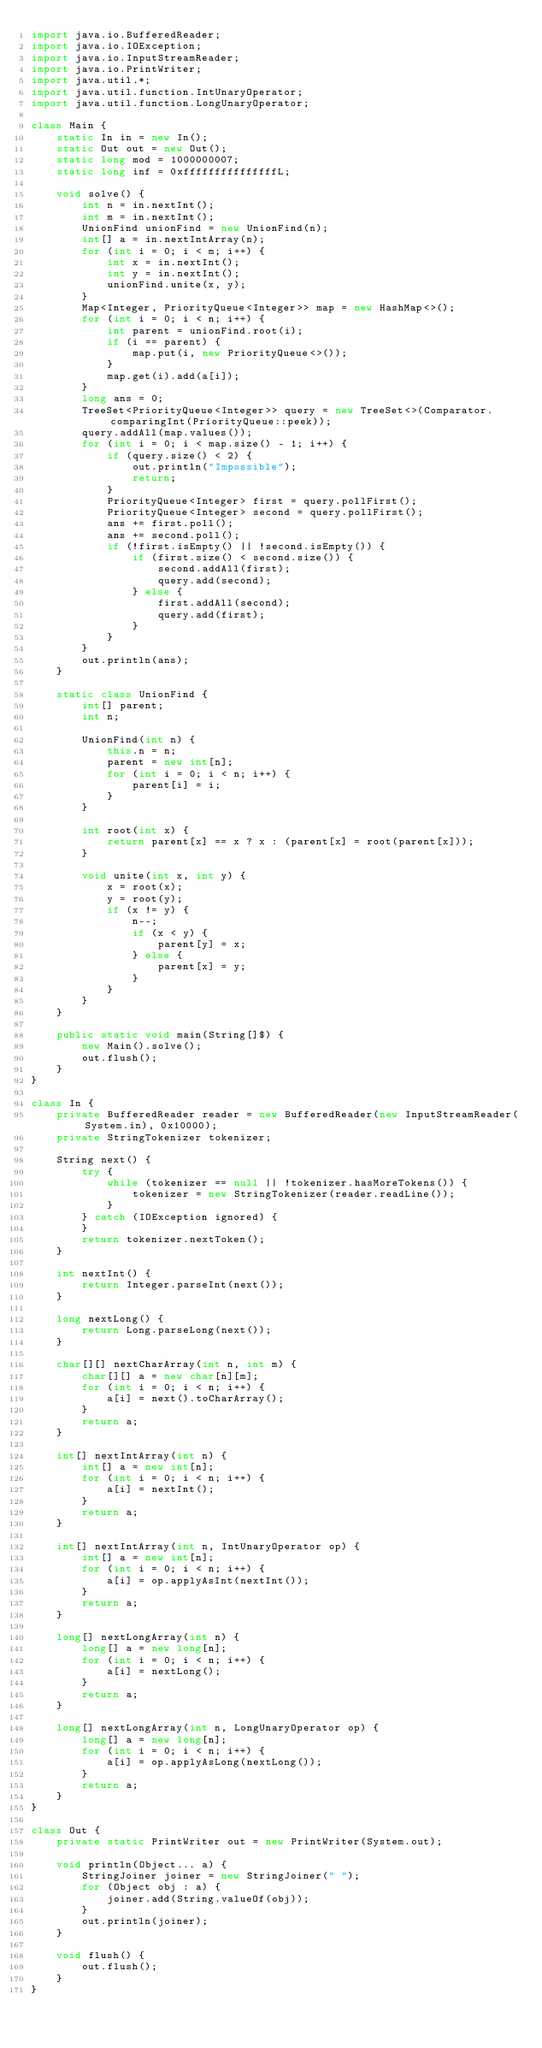<code> <loc_0><loc_0><loc_500><loc_500><_Java_>import java.io.BufferedReader;
import java.io.IOException;
import java.io.InputStreamReader;
import java.io.PrintWriter;
import java.util.*;
import java.util.function.IntUnaryOperator;
import java.util.function.LongUnaryOperator;

class Main {
    static In in = new In();
    static Out out = new Out();
    static long mod = 1000000007;
    static long inf = 0xfffffffffffffffL;

    void solve() {
        int n = in.nextInt();
        int m = in.nextInt();
        UnionFind unionFind = new UnionFind(n);
        int[] a = in.nextIntArray(n);
        for (int i = 0; i < m; i++) {
            int x = in.nextInt();
            int y = in.nextInt();
            unionFind.unite(x, y);
        }
        Map<Integer, PriorityQueue<Integer>> map = new HashMap<>();
        for (int i = 0; i < n; i++) {
            int parent = unionFind.root(i);
            if (i == parent) {
                map.put(i, new PriorityQueue<>());
            }
            map.get(i).add(a[i]);
        }
        long ans = 0;
        TreeSet<PriorityQueue<Integer>> query = new TreeSet<>(Comparator.comparingInt(PriorityQueue::peek));
        query.addAll(map.values());
        for (int i = 0; i < map.size() - 1; i++) {
            if (query.size() < 2) {
                out.println("Impossible");
                return;
            }
            PriorityQueue<Integer> first = query.pollFirst();
            PriorityQueue<Integer> second = query.pollFirst();
            ans += first.poll();
            ans += second.poll();
            if (!first.isEmpty() || !second.isEmpty()) {
                if (first.size() < second.size()) {
                    second.addAll(first);
                    query.add(second);
                } else {
                    first.addAll(second);
                    query.add(first);
                }
            }
        }
        out.println(ans);
    }

    static class UnionFind {
        int[] parent;
        int n;

        UnionFind(int n) {
            this.n = n;
            parent = new int[n];
            for (int i = 0; i < n; i++) {
                parent[i] = i;
            }
        }

        int root(int x) {
            return parent[x] == x ? x : (parent[x] = root(parent[x]));
        }

        void unite(int x, int y) {
            x = root(x);
            y = root(y);
            if (x != y) {
                n--;
                if (x < y) {
                    parent[y] = x;
                } else {
                    parent[x] = y;
                }
            }
        }
    }

    public static void main(String[]$) {
        new Main().solve();
        out.flush();
    }
}

class In {
    private BufferedReader reader = new BufferedReader(new InputStreamReader(System.in), 0x10000);
    private StringTokenizer tokenizer;

    String next() {
        try {
            while (tokenizer == null || !tokenizer.hasMoreTokens()) {
                tokenizer = new StringTokenizer(reader.readLine());
            }
        } catch (IOException ignored) {
        }
        return tokenizer.nextToken();
    }

    int nextInt() {
        return Integer.parseInt(next());
    }

    long nextLong() {
        return Long.parseLong(next());
    }

    char[][] nextCharArray(int n, int m) {
        char[][] a = new char[n][m];
        for (int i = 0; i < n; i++) {
            a[i] = next().toCharArray();
        }
        return a;
    }

    int[] nextIntArray(int n) {
        int[] a = new int[n];
        for (int i = 0; i < n; i++) {
            a[i] = nextInt();
        }
        return a;
    }

    int[] nextIntArray(int n, IntUnaryOperator op) {
        int[] a = new int[n];
        for (int i = 0; i < n; i++) {
            a[i] = op.applyAsInt(nextInt());
        }
        return a;
    }

    long[] nextLongArray(int n) {
        long[] a = new long[n];
        for (int i = 0; i < n; i++) {
            a[i] = nextLong();
        }
        return a;
    }

    long[] nextLongArray(int n, LongUnaryOperator op) {
        long[] a = new long[n];
        for (int i = 0; i < n; i++) {
            a[i] = op.applyAsLong(nextLong());
        }
        return a;
    }
}

class Out {
    private static PrintWriter out = new PrintWriter(System.out);

    void println(Object... a) {
        StringJoiner joiner = new StringJoiner(" ");
        for (Object obj : a) {
            joiner.add(String.valueOf(obj));
        }
        out.println(joiner);
    }

    void flush() {
        out.flush();
    }
}
</code> 